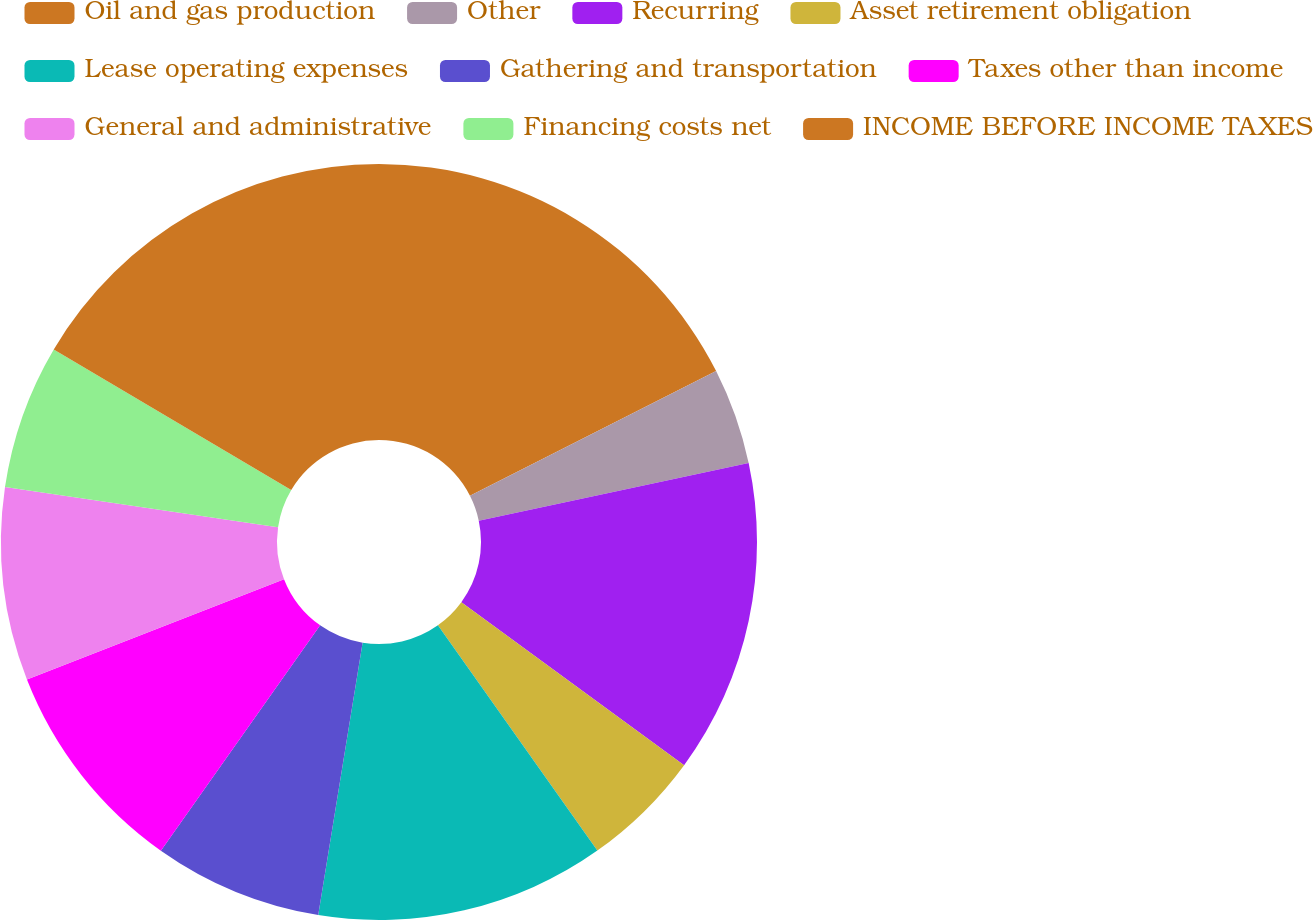Convert chart to OTSL. <chart><loc_0><loc_0><loc_500><loc_500><pie_chart><fcel>Oil and gas production<fcel>Other<fcel>Recurring<fcel>Asset retirement obligation<fcel>Lease operating expenses<fcel>Gathering and transportation<fcel>Taxes other than income<fcel>General and administrative<fcel>Financing costs net<fcel>INCOME BEFORE INCOME TAXES<nl><fcel>17.53%<fcel>4.12%<fcel>13.4%<fcel>5.15%<fcel>12.37%<fcel>7.22%<fcel>9.28%<fcel>8.25%<fcel>6.19%<fcel>16.49%<nl></chart> 